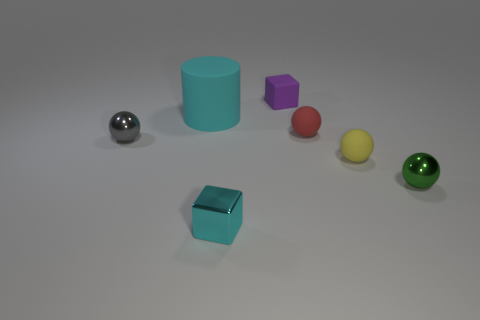Add 2 green metal objects. How many objects exist? 9 Subtract all red spheres. How many spheres are left? 3 Subtract all red rubber balls. How many balls are left? 3 Subtract 1 balls. How many balls are left? 3 Subtract all balls. How many objects are left? 3 Subtract all brown balls. Subtract all purple cubes. How many balls are left? 4 Subtract all tiny gray blocks. Subtract all small red balls. How many objects are left? 6 Add 4 tiny cyan metal things. How many tiny cyan metal things are left? 5 Add 3 big brown rubber blocks. How many big brown rubber blocks exist? 3 Subtract 1 red spheres. How many objects are left? 6 